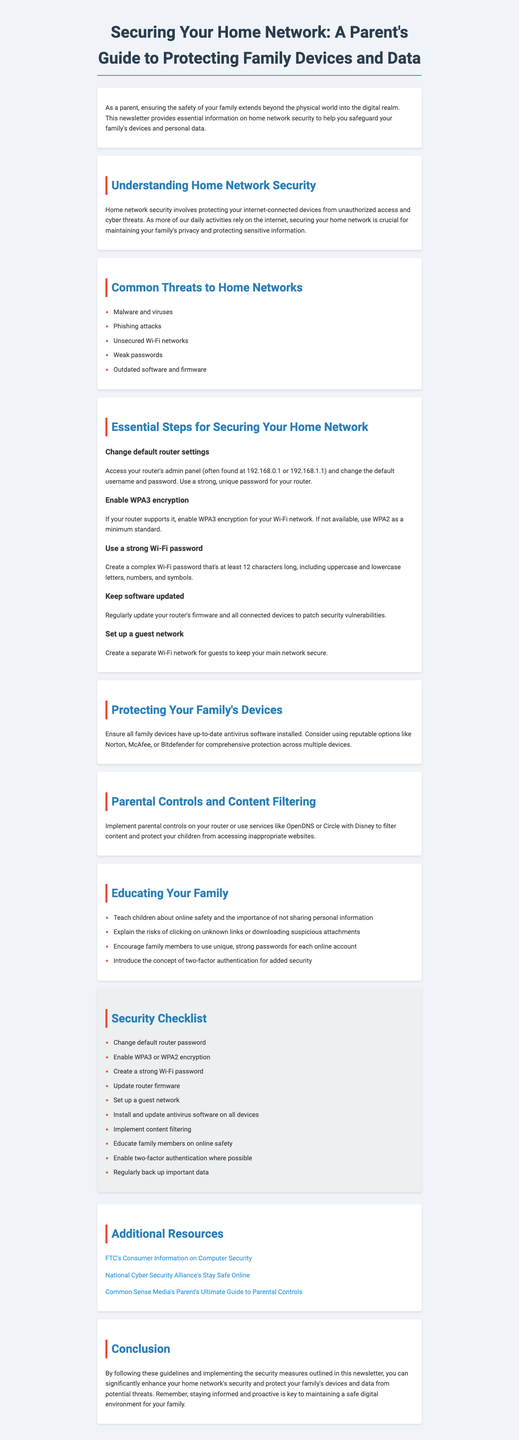What is the title of the newsletter? The title is stated at the beginning of the document and represents the main focus of the content.
Answer: Securing Your Home Network: A Parent's Guide to Protecting Family Devices and Data How many common threats to home networks are listed? The document outlines several threats under a specific section. Counting those gives the total number.
Answer: 5 What is the minimum Wi-Fi encryption standard recommended? The document states encryption standards under a specific section outlining steps for securing the home network.
Answer: WPA2 Name one service mentioned for content filtering. The document lists services that provide content filtering under a dedicated section.
Answer: OpenDNS What essential step involves changing default settings? One of the main steps for securing the home network involves modifying initial settings of a device, which is specified in the document.
Answer: Change default router settings How many items are in the security checklist? The document provides a checklist for home network security, counting the items listed gives the total number.
Answer: 10 What is advised for protecting family devices? The document mentions a specific action that should be taken regarding the protection of family devices in one of its sections.
Answer: Install and update antivirus software on all devices Which section provides guidance on educating family members? The document clearly states a section dedicated to teaching family members about online safety and security practices.
Answer: Educating Your Family What term describes the additional resources provided? The document has a section where more references and links are given for further reading or tools.
Answer: Additional Resources 